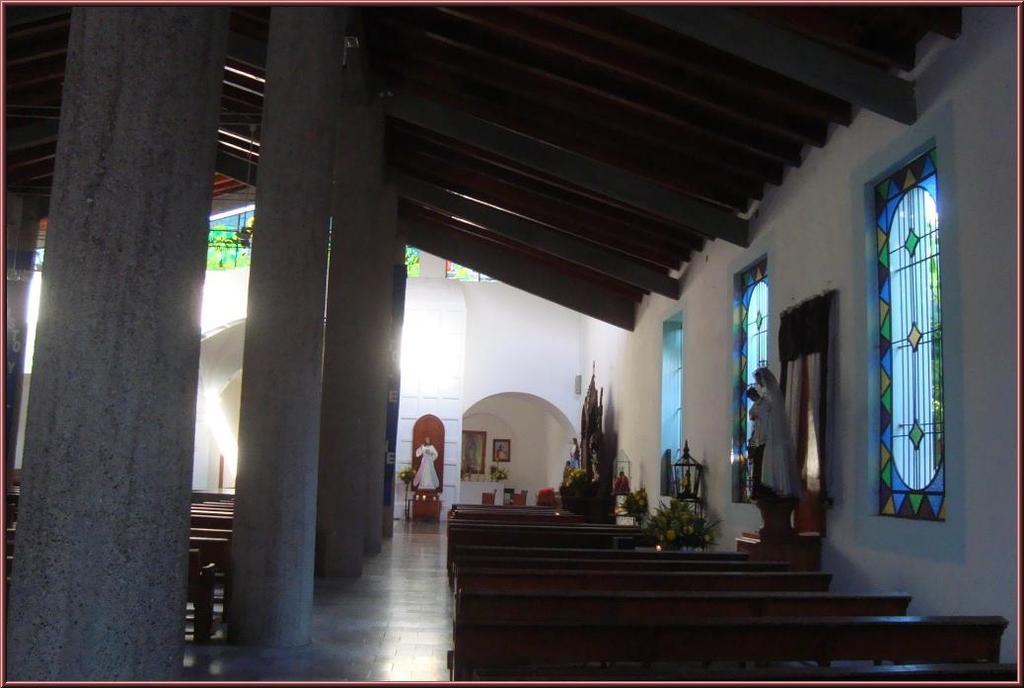Please provide a concise description of this image. In this picture we can see pillars, benches on the floor, statues, plants, windows and some objects and in the background we can see frames on the wall. 